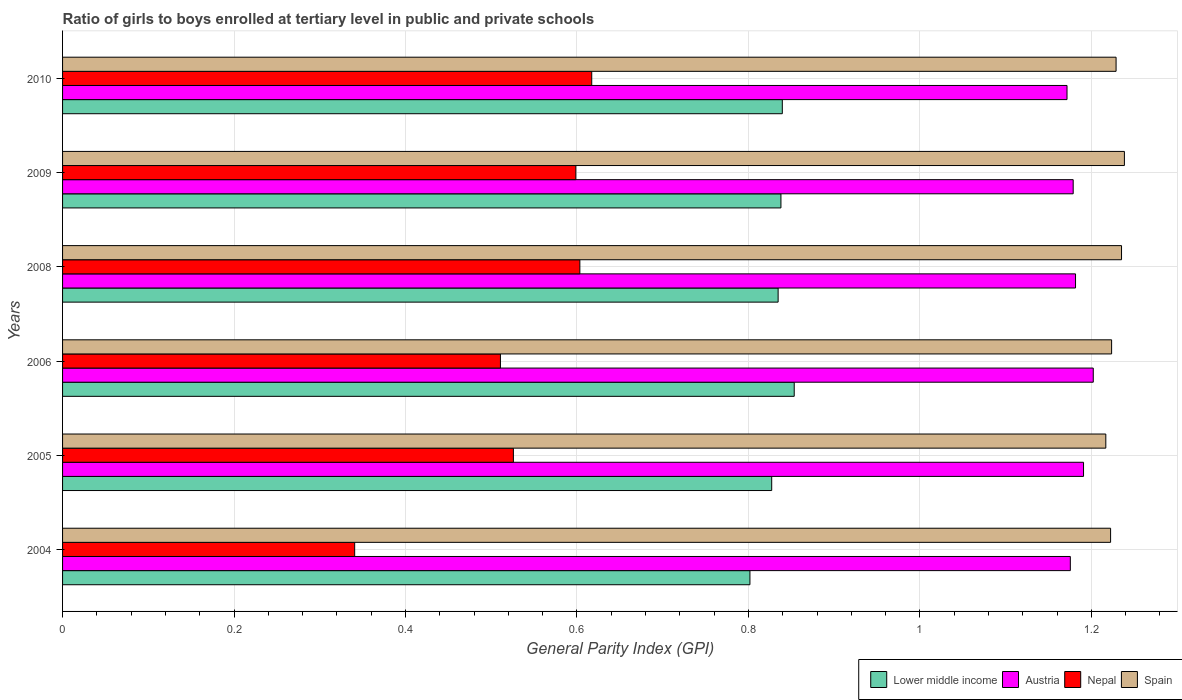Are the number of bars per tick equal to the number of legend labels?
Provide a succinct answer. Yes. How many bars are there on the 5th tick from the top?
Keep it short and to the point. 4. How many bars are there on the 5th tick from the bottom?
Give a very brief answer. 4. What is the label of the 3rd group of bars from the top?
Keep it short and to the point. 2008. What is the general parity index in Spain in 2009?
Offer a very short reply. 1.24. Across all years, what is the maximum general parity index in Lower middle income?
Provide a succinct answer. 0.85. Across all years, what is the minimum general parity index in Spain?
Offer a terse response. 1.22. In which year was the general parity index in Nepal minimum?
Offer a terse response. 2004. What is the total general parity index in Spain in the graph?
Your response must be concise. 7.37. What is the difference between the general parity index in Nepal in 2004 and that in 2009?
Your response must be concise. -0.26. What is the difference between the general parity index in Lower middle income in 2004 and the general parity index in Spain in 2010?
Keep it short and to the point. -0.43. What is the average general parity index in Spain per year?
Offer a very short reply. 1.23. In the year 2006, what is the difference between the general parity index in Nepal and general parity index in Austria?
Give a very brief answer. -0.69. What is the ratio of the general parity index in Lower middle income in 2009 to that in 2010?
Provide a short and direct response. 1. What is the difference between the highest and the second highest general parity index in Spain?
Ensure brevity in your answer.  0. What is the difference between the highest and the lowest general parity index in Nepal?
Your answer should be compact. 0.28. Is the sum of the general parity index in Austria in 2008 and 2010 greater than the maximum general parity index in Lower middle income across all years?
Offer a very short reply. Yes. Is it the case that in every year, the sum of the general parity index in Spain and general parity index in Nepal is greater than the sum of general parity index in Lower middle income and general parity index in Austria?
Give a very brief answer. No. What does the 4th bar from the top in 2010 represents?
Give a very brief answer. Lower middle income. What does the 1st bar from the bottom in 2004 represents?
Ensure brevity in your answer.  Lower middle income. Is it the case that in every year, the sum of the general parity index in Spain and general parity index in Nepal is greater than the general parity index in Austria?
Offer a very short reply. Yes. Are all the bars in the graph horizontal?
Give a very brief answer. Yes. What is the difference between two consecutive major ticks on the X-axis?
Provide a short and direct response. 0.2. Does the graph contain any zero values?
Keep it short and to the point. No. Where does the legend appear in the graph?
Ensure brevity in your answer.  Bottom right. How many legend labels are there?
Ensure brevity in your answer.  4. What is the title of the graph?
Provide a short and direct response. Ratio of girls to boys enrolled at tertiary level in public and private schools. What is the label or title of the X-axis?
Your response must be concise. General Parity Index (GPI). What is the General Parity Index (GPI) of Lower middle income in 2004?
Your response must be concise. 0.8. What is the General Parity Index (GPI) in Austria in 2004?
Keep it short and to the point. 1.18. What is the General Parity Index (GPI) of Nepal in 2004?
Ensure brevity in your answer.  0.34. What is the General Parity Index (GPI) in Spain in 2004?
Offer a very short reply. 1.22. What is the General Parity Index (GPI) in Lower middle income in 2005?
Provide a succinct answer. 0.83. What is the General Parity Index (GPI) in Austria in 2005?
Offer a very short reply. 1.19. What is the General Parity Index (GPI) in Nepal in 2005?
Offer a terse response. 0.53. What is the General Parity Index (GPI) in Spain in 2005?
Offer a very short reply. 1.22. What is the General Parity Index (GPI) in Lower middle income in 2006?
Provide a succinct answer. 0.85. What is the General Parity Index (GPI) in Austria in 2006?
Your answer should be very brief. 1.2. What is the General Parity Index (GPI) in Nepal in 2006?
Make the answer very short. 0.51. What is the General Parity Index (GPI) of Spain in 2006?
Provide a short and direct response. 1.22. What is the General Parity Index (GPI) of Lower middle income in 2008?
Offer a very short reply. 0.83. What is the General Parity Index (GPI) of Austria in 2008?
Make the answer very short. 1.18. What is the General Parity Index (GPI) of Nepal in 2008?
Keep it short and to the point. 0.6. What is the General Parity Index (GPI) in Spain in 2008?
Your answer should be very brief. 1.24. What is the General Parity Index (GPI) of Lower middle income in 2009?
Offer a very short reply. 0.84. What is the General Parity Index (GPI) in Austria in 2009?
Offer a very short reply. 1.18. What is the General Parity Index (GPI) of Nepal in 2009?
Your response must be concise. 0.6. What is the General Parity Index (GPI) in Spain in 2009?
Provide a short and direct response. 1.24. What is the General Parity Index (GPI) of Lower middle income in 2010?
Provide a short and direct response. 0.84. What is the General Parity Index (GPI) of Austria in 2010?
Provide a short and direct response. 1.17. What is the General Parity Index (GPI) in Nepal in 2010?
Give a very brief answer. 0.62. What is the General Parity Index (GPI) in Spain in 2010?
Your response must be concise. 1.23. Across all years, what is the maximum General Parity Index (GPI) in Lower middle income?
Provide a succinct answer. 0.85. Across all years, what is the maximum General Parity Index (GPI) in Austria?
Your answer should be compact. 1.2. Across all years, what is the maximum General Parity Index (GPI) of Nepal?
Offer a very short reply. 0.62. Across all years, what is the maximum General Parity Index (GPI) of Spain?
Keep it short and to the point. 1.24. Across all years, what is the minimum General Parity Index (GPI) in Lower middle income?
Ensure brevity in your answer.  0.8. Across all years, what is the minimum General Parity Index (GPI) in Austria?
Your response must be concise. 1.17. Across all years, what is the minimum General Parity Index (GPI) in Nepal?
Keep it short and to the point. 0.34. Across all years, what is the minimum General Parity Index (GPI) in Spain?
Your response must be concise. 1.22. What is the total General Parity Index (GPI) in Lower middle income in the graph?
Offer a terse response. 4.99. What is the total General Parity Index (GPI) of Austria in the graph?
Your response must be concise. 7.1. What is the total General Parity Index (GPI) in Nepal in the graph?
Give a very brief answer. 3.2. What is the total General Parity Index (GPI) in Spain in the graph?
Your answer should be very brief. 7.37. What is the difference between the General Parity Index (GPI) of Lower middle income in 2004 and that in 2005?
Keep it short and to the point. -0.03. What is the difference between the General Parity Index (GPI) in Austria in 2004 and that in 2005?
Ensure brevity in your answer.  -0.02. What is the difference between the General Parity Index (GPI) of Nepal in 2004 and that in 2005?
Provide a succinct answer. -0.19. What is the difference between the General Parity Index (GPI) in Spain in 2004 and that in 2005?
Give a very brief answer. 0.01. What is the difference between the General Parity Index (GPI) in Lower middle income in 2004 and that in 2006?
Provide a short and direct response. -0.05. What is the difference between the General Parity Index (GPI) in Austria in 2004 and that in 2006?
Keep it short and to the point. -0.03. What is the difference between the General Parity Index (GPI) in Nepal in 2004 and that in 2006?
Offer a terse response. -0.17. What is the difference between the General Parity Index (GPI) of Spain in 2004 and that in 2006?
Provide a succinct answer. -0. What is the difference between the General Parity Index (GPI) in Lower middle income in 2004 and that in 2008?
Offer a very short reply. -0.03. What is the difference between the General Parity Index (GPI) in Austria in 2004 and that in 2008?
Provide a succinct answer. -0.01. What is the difference between the General Parity Index (GPI) in Nepal in 2004 and that in 2008?
Make the answer very short. -0.26. What is the difference between the General Parity Index (GPI) of Spain in 2004 and that in 2008?
Provide a succinct answer. -0.01. What is the difference between the General Parity Index (GPI) in Lower middle income in 2004 and that in 2009?
Make the answer very short. -0.04. What is the difference between the General Parity Index (GPI) in Austria in 2004 and that in 2009?
Ensure brevity in your answer.  -0. What is the difference between the General Parity Index (GPI) in Nepal in 2004 and that in 2009?
Offer a very short reply. -0.26. What is the difference between the General Parity Index (GPI) in Spain in 2004 and that in 2009?
Give a very brief answer. -0.02. What is the difference between the General Parity Index (GPI) of Lower middle income in 2004 and that in 2010?
Provide a succinct answer. -0.04. What is the difference between the General Parity Index (GPI) of Austria in 2004 and that in 2010?
Your response must be concise. 0. What is the difference between the General Parity Index (GPI) in Nepal in 2004 and that in 2010?
Keep it short and to the point. -0.28. What is the difference between the General Parity Index (GPI) in Spain in 2004 and that in 2010?
Provide a succinct answer. -0.01. What is the difference between the General Parity Index (GPI) of Lower middle income in 2005 and that in 2006?
Your response must be concise. -0.03. What is the difference between the General Parity Index (GPI) of Austria in 2005 and that in 2006?
Your answer should be compact. -0.01. What is the difference between the General Parity Index (GPI) of Nepal in 2005 and that in 2006?
Keep it short and to the point. 0.02. What is the difference between the General Parity Index (GPI) of Spain in 2005 and that in 2006?
Give a very brief answer. -0.01. What is the difference between the General Parity Index (GPI) of Lower middle income in 2005 and that in 2008?
Provide a succinct answer. -0.01. What is the difference between the General Parity Index (GPI) in Austria in 2005 and that in 2008?
Keep it short and to the point. 0.01. What is the difference between the General Parity Index (GPI) of Nepal in 2005 and that in 2008?
Keep it short and to the point. -0.08. What is the difference between the General Parity Index (GPI) of Spain in 2005 and that in 2008?
Keep it short and to the point. -0.02. What is the difference between the General Parity Index (GPI) of Lower middle income in 2005 and that in 2009?
Offer a very short reply. -0.01. What is the difference between the General Parity Index (GPI) in Austria in 2005 and that in 2009?
Give a very brief answer. 0.01. What is the difference between the General Parity Index (GPI) of Nepal in 2005 and that in 2009?
Make the answer very short. -0.07. What is the difference between the General Parity Index (GPI) in Spain in 2005 and that in 2009?
Give a very brief answer. -0.02. What is the difference between the General Parity Index (GPI) of Lower middle income in 2005 and that in 2010?
Offer a terse response. -0.01. What is the difference between the General Parity Index (GPI) of Austria in 2005 and that in 2010?
Offer a very short reply. 0.02. What is the difference between the General Parity Index (GPI) in Nepal in 2005 and that in 2010?
Your answer should be compact. -0.09. What is the difference between the General Parity Index (GPI) in Spain in 2005 and that in 2010?
Offer a terse response. -0.01. What is the difference between the General Parity Index (GPI) in Lower middle income in 2006 and that in 2008?
Give a very brief answer. 0.02. What is the difference between the General Parity Index (GPI) of Austria in 2006 and that in 2008?
Make the answer very short. 0.02. What is the difference between the General Parity Index (GPI) in Nepal in 2006 and that in 2008?
Offer a very short reply. -0.09. What is the difference between the General Parity Index (GPI) in Spain in 2006 and that in 2008?
Make the answer very short. -0.01. What is the difference between the General Parity Index (GPI) in Lower middle income in 2006 and that in 2009?
Make the answer very short. 0.02. What is the difference between the General Parity Index (GPI) of Austria in 2006 and that in 2009?
Your answer should be compact. 0.02. What is the difference between the General Parity Index (GPI) in Nepal in 2006 and that in 2009?
Give a very brief answer. -0.09. What is the difference between the General Parity Index (GPI) of Spain in 2006 and that in 2009?
Keep it short and to the point. -0.01. What is the difference between the General Parity Index (GPI) of Lower middle income in 2006 and that in 2010?
Your answer should be compact. 0.01. What is the difference between the General Parity Index (GPI) in Austria in 2006 and that in 2010?
Provide a short and direct response. 0.03. What is the difference between the General Parity Index (GPI) of Nepal in 2006 and that in 2010?
Provide a succinct answer. -0.11. What is the difference between the General Parity Index (GPI) in Spain in 2006 and that in 2010?
Ensure brevity in your answer.  -0.01. What is the difference between the General Parity Index (GPI) in Lower middle income in 2008 and that in 2009?
Provide a short and direct response. -0. What is the difference between the General Parity Index (GPI) of Austria in 2008 and that in 2009?
Provide a short and direct response. 0. What is the difference between the General Parity Index (GPI) in Nepal in 2008 and that in 2009?
Offer a very short reply. 0. What is the difference between the General Parity Index (GPI) of Spain in 2008 and that in 2009?
Offer a very short reply. -0. What is the difference between the General Parity Index (GPI) of Lower middle income in 2008 and that in 2010?
Ensure brevity in your answer.  -0. What is the difference between the General Parity Index (GPI) of Austria in 2008 and that in 2010?
Provide a succinct answer. 0.01. What is the difference between the General Parity Index (GPI) of Nepal in 2008 and that in 2010?
Make the answer very short. -0.01. What is the difference between the General Parity Index (GPI) of Spain in 2008 and that in 2010?
Ensure brevity in your answer.  0.01. What is the difference between the General Parity Index (GPI) in Lower middle income in 2009 and that in 2010?
Provide a short and direct response. -0. What is the difference between the General Parity Index (GPI) in Austria in 2009 and that in 2010?
Give a very brief answer. 0.01. What is the difference between the General Parity Index (GPI) of Nepal in 2009 and that in 2010?
Offer a terse response. -0.02. What is the difference between the General Parity Index (GPI) of Spain in 2009 and that in 2010?
Your answer should be compact. 0.01. What is the difference between the General Parity Index (GPI) of Lower middle income in 2004 and the General Parity Index (GPI) of Austria in 2005?
Make the answer very short. -0.39. What is the difference between the General Parity Index (GPI) in Lower middle income in 2004 and the General Parity Index (GPI) in Nepal in 2005?
Keep it short and to the point. 0.28. What is the difference between the General Parity Index (GPI) in Lower middle income in 2004 and the General Parity Index (GPI) in Spain in 2005?
Give a very brief answer. -0.42. What is the difference between the General Parity Index (GPI) in Austria in 2004 and the General Parity Index (GPI) in Nepal in 2005?
Make the answer very short. 0.65. What is the difference between the General Parity Index (GPI) of Austria in 2004 and the General Parity Index (GPI) of Spain in 2005?
Offer a very short reply. -0.04. What is the difference between the General Parity Index (GPI) of Nepal in 2004 and the General Parity Index (GPI) of Spain in 2005?
Your answer should be very brief. -0.88. What is the difference between the General Parity Index (GPI) in Lower middle income in 2004 and the General Parity Index (GPI) in Austria in 2006?
Keep it short and to the point. -0.4. What is the difference between the General Parity Index (GPI) in Lower middle income in 2004 and the General Parity Index (GPI) in Nepal in 2006?
Offer a very short reply. 0.29. What is the difference between the General Parity Index (GPI) in Lower middle income in 2004 and the General Parity Index (GPI) in Spain in 2006?
Keep it short and to the point. -0.42. What is the difference between the General Parity Index (GPI) of Austria in 2004 and the General Parity Index (GPI) of Nepal in 2006?
Your answer should be compact. 0.66. What is the difference between the General Parity Index (GPI) of Austria in 2004 and the General Parity Index (GPI) of Spain in 2006?
Offer a very short reply. -0.05. What is the difference between the General Parity Index (GPI) in Nepal in 2004 and the General Parity Index (GPI) in Spain in 2006?
Offer a terse response. -0.88. What is the difference between the General Parity Index (GPI) in Lower middle income in 2004 and the General Parity Index (GPI) in Austria in 2008?
Your answer should be compact. -0.38. What is the difference between the General Parity Index (GPI) in Lower middle income in 2004 and the General Parity Index (GPI) in Nepal in 2008?
Give a very brief answer. 0.2. What is the difference between the General Parity Index (GPI) in Lower middle income in 2004 and the General Parity Index (GPI) in Spain in 2008?
Make the answer very short. -0.43. What is the difference between the General Parity Index (GPI) in Austria in 2004 and the General Parity Index (GPI) in Nepal in 2008?
Offer a terse response. 0.57. What is the difference between the General Parity Index (GPI) in Austria in 2004 and the General Parity Index (GPI) in Spain in 2008?
Offer a very short reply. -0.06. What is the difference between the General Parity Index (GPI) in Nepal in 2004 and the General Parity Index (GPI) in Spain in 2008?
Ensure brevity in your answer.  -0.89. What is the difference between the General Parity Index (GPI) of Lower middle income in 2004 and the General Parity Index (GPI) of Austria in 2009?
Offer a very short reply. -0.38. What is the difference between the General Parity Index (GPI) in Lower middle income in 2004 and the General Parity Index (GPI) in Nepal in 2009?
Your answer should be very brief. 0.2. What is the difference between the General Parity Index (GPI) in Lower middle income in 2004 and the General Parity Index (GPI) in Spain in 2009?
Give a very brief answer. -0.44. What is the difference between the General Parity Index (GPI) of Austria in 2004 and the General Parity Index (GPI) of Nepal in 2009?
Provide a short and direct response. 0.58. What is the difference between the General Parity Index (GPI) of Austria in 2004 and the General Parity Index (GPI) of Spain in 2009?
Make the answer very short. -0.06. What is the difference between the General Parity Index (GPI) in Nepal in 2004 and the General Parity Index (GPI) in Spain in 2009?
Offer a terse response. -0.9. What is the difference between the General Parity Index (GPI) of Lower middle income in 2004 and the General Parity Index (GPI) of Austria in 2010?
Provide a short and direct response. -0.37. What is the difference between the General Parity Index (GPI) in Lower middle income in 2004 and the General Parity Index (GPI) in Nepal in 2010?
Provide a succinct answer. 0.18. What is the difference between the General Parity Index (GPI) in Lower middle income in 2004 and the General Parity Index (GPI) in Spain in 2010?
Ensure brevity in your answer.  -0.43. What is the difference between the General Parity Index (GPI) in Austria in 2004 and the General Parity Index (GPI) in Nepal in 2010?
Offer a very short reply. 0.56. What is the difference between the General Parity Index (GPI) in Austria in 2004 and the General Parity Index (GPI) in Spain in 2010?
Your answer should be compact. -0.05. What is the difference between the General Parity Index (GPI) in Nepal in 2004 and the General Parity Index (GPI) in Spain in 2010?
Provide a succinct answer. -0.89. What is the difference between the General Parity Index (GPI) of Lower middle income in 2005 and the General Parity Index (GPI) of Austria in 2006?
Your answer should be compact. -0.38. What is the difference between the General Parity Index (GPI) of Lower middle income in 2005 and the General Parity Index (GPI) of Nepal in 2006?
Your answer should be compact. 0.32. What is the difference between the General Parity Index (GPI) in Lower middle income in 2005 and the General Parity Index (GPI) in Spain in 2006?
Ensure brevity in your answer.  -0.4. What is the difference between the General Parity Index (GPI) in Austria in 2005 and the General Parity Index (GPI) in Nepal in 2006?
Provide a succinct answer. 0.68. What is the difference between the General Parity Index (GPI) in Austria in 2005 and the General Parity Index (GPI) in Spain in 2006?
Make the answer very short. -0.03. What is the difference between the General Parity Index (GPI) of Nepal in 2005 and the General Parity Index (GPI) of Spain in 2006?
Provide a succinct answer. -0.7. What is the difference between the General Parity Index (GPI) in Lower middle income in 2005 and the General Parity Index (GPI) in Austria in 2008?
Offer a very short reply. -0.35. What is the difference between the General Parity Index (GPI) of Lower middle income in 2005 and the General Parity Index (GPI) of Nepal in 2008?
Offer a very short reply. 0.22. What is the difference between the General Parity Index (GPI) of Lower middle income in 2005 and the General Parity Index (GPI) of Spain in 2008?
Your response must be concise. -0.41. What is the difference between the General Parity Index (GPI) in Austria in 2005 and the General Parity Index (GPI) in Nepal in 2008?
Keep it short and to the point. 0.59. What is the difference between the General Parity Index (GPI) of Austria in 2005 and the General Parity Index (GPI) of Spain in 2008?
Offer a very short reply. -0.04. What is the difference between the General Parity Index (GPI) in Nepal in 2005 and the General Parity Index (GPI) in Spain in 2008?
Give a very brief answer. -0.71. What is the difference between the General Parity Index (GPI) of Lower middle income in 2005 and the General Parity Index (GPI) of Austria in 2009?
Ensure brevity in your answer.  -0.35. What is the difference between the General Parity Index (GPI) in Lower middle income in 2005 and the General Parity Index (GPI) in Nepal in 2009?
Make the answer very short. 0.23. What is the difference between the General Parity Index (GPI) in Lower middle income in 2005 and the General Parity Index (GPI) in Spain in 2009?
Offer a very short reply. -0.41. What is the difference between the General Parity Index (GPI) in Austria in 2005 and the General Parity Index (GPI) in Nepal in 2009?
Your response must be concise. 0.59. What is the difference between the General Parity Index (GPI) in Austria in 2005 and the General Parity Index (GPI) in Spain in 2009?
Your response must be concise. -0.05. What is the difference between the General Parity Index (GPI) in Nepal in 2005 and the General Parity Index (GPI) in Spain in 2009?
Give a very brief answer. -0.71. What is the difference between the General Parity Index (GPI) of Lower middle income in 2005 and the General Parity Index (GPI) of Austria in 2010?
Provide a short and direct response. -0.34. What is the difference between the General Parity Index (GPI) of Lower middle income in 2005 and the General Parity Index (GPI) of Nepal in 2010?
Offer a very short reply. 0.21. What is the difference between the General Parity Index (GPI) in Lower middle income in 2005 and the General Parity Index (GPI) in Spain in 2010?
Your answer should be very brief. -0.4. What is the difference between the General Parity Index (GPI) of Austria in 2005 and the General Parity Index (GPI) of Nepal in 2010?
Provide a succinct answer. 0.57. What is the difference between the General Parity Index (GPI) of Austria in 2005 and the General Parity Index (GPI) of Spain in 2010?
Your response must be concise. -0.04. What is the difference between the General Parity Index (GPI) in Nepal in 2005 and the General Parity Index (GPI) in Spain in 2010?
Ensure brevity in your answer.  -0.7. What is the difference between the General Parity Index (GPI) in Lower middle income in 2006 and the General Parity Index (GPI) in Austria in 2008?
Give a very brief answer. -0.33. What is the difference between the General Parity Index (GPI) in Lower middle income in 2006 and the General Parity Index (GPI) in Nepal in 2008?
Provide a short and direct response. 0.25. What is the difference between the General Parity Index (GPI) of Lower middle income in 2006 and the General Parity Index (GPI) of Spain in 2008?
Make the answer very short. -0.38. What is the difference between the General Parity Index (GPI) of Austria in 2006 and the General Parity Index (GPI) of Nepal in 2008?
Your response must be concise. 0.6. What is the difference between the General Parity Index (GPI) of Austria in 2006 and the General Parity Index (GPI) of Spain in 2008?
Provide a short and direct response. -0.03. What is the difference between the General Parity Index (GPI) of Nepal in 2006 and the General Parity Index (GPI) of Spain in 2008?
Provide a short and direct response. -0.72. What is the difference between the General Parity Index (GPI) of Lower middle income in 2006 and the General Parity Index (GPI) of Austria in 2009?
Your answer should be very brief. -0.33. What is the difference between the General Parity Index (GPI) in Lower middle income in 2006 and the General Parity Index (GPI) in Nepal in 2009?
Offer a terse response. 0.25. What is the difference between the General Parity Index (GPI) in Lower middle income in 2006 and the General Parity Index (GPI) in Spain in 2009?
Your answer should be compact. -0.39. What is the difference between the General Parity Index (GPI) of Austria in 2006 and the General Parity Index (GPI) of Nepal in 2009?
Your response must be concise. 0.6. What is the difference between the General Parity Index (GPI) of Austria in 2006 and the General Parity Index (GPI) of Spain in 2009?
Offer a terse response. -0.04. What is the difference between the General Parity Index (GPI) in Nepal in 2006 and the General Parity Index (GPI) in Spain in 2009?
Offer a terse response. -0.73. What is the difference between the General Parity Index (GPI) of Lower middle income in 2006 and the General Parity Index (GPI) of Austria in 2010?
Your answer should be very brief. -0.32. What is the difference between the General Parity Index (GPI) of Lower middle income in 2006 and the General Parity Index (GPI) of Nepal in 2010?
Your response must be concise. 0.24. What is the difference between the General Parity Index (GPI) of Lower middle income in 2006 and the General Parity Index (GPI) of Spain in 2010?
Give a very brief answer. -0.38. What is the difference between the General Parity Index (GPI) of Austria in 2006 and the General Parity Index (GPI) of Nepal in 2010?
Your response must be concise. 0.58. What is the difference between the General Parity Index (GPI) in Austria in 2006 and the General Parity Index (GPI) in Spain in 2010?
Offer a very short reply. -0.03. What is the difference between the General Parity Index (GPI) in Nepal in 2006 and the General Parity Index (GPI) in Spain in 2010?
Ensure brevity in your answer.  -0.72. What is the difference between the General Parity Index (GPI) of Lower middle income in 2008 and the General Parity Index (GPI) of Austria in 2009?
Ensure brevity in your answer.  -0.34. What is the difference between the General Parity Index (GPI) of Lower middle income in 2008 and the General Parity Index (GPI) of Nepal in 2009?
Provide a succinct answer. 0.24. What is the difference between the General Parity Index (GPI) of Lower middle income in 2008 and the General Parity Index (GPI) of Spain in 2009?
Provide a succinct answer. -0.4. What is the difference between the General Parity Index (GPI) in Austria in 2008 and the General Parity Index (GPI) in Nepal in 2009?
Give a very brief answer. 0.58. What is the difference between the General Parity Index (GPI) of Austria in 2008 and the General Parity Index (GPI) of Spain in 2009?
Keep it short and to the point. -0.06. What is the difference between the General Parity Index (GPI) of Nepal in 2008 and the General Parity Index (GPI) of Spain in 2009?
Provide a succinct answer. -0.64. What is the difference between the General Parity Index (GPI) in Lower middle income in 2008 and the General Parity Index (GPI) in Austria in 2010?
Offer a terse response. -0.34. What is the difference between the General Parity Index (GPI) in Lower middle income in 2008 and the General Parity Index (GPI) in Nepal in 2010?
Give a very brief answer. 0.22. What is the difference between the General Parity Index (GPI) of Lower middle income in 2008 and the General Parity Index (GPI) of Spain in 2010?
Provide a succinct answer. -0.39. What is the difference between the General Parity Index (GPI) in Austria in 2008 and the General Parity Index (GPI) in Nepal in 2010?
Offer a very short reply. 0.56. What is the difference between the General Parity Index (GPI) of Austria in 2008 and the General Parity Index (GPI) of Spain in 2010?
Keep it short and to the point. -0.05. What is the difference between the General Parity Index (GPI) of Nepal in 2008 and the General Parity Index (GPI) of Spain in 2010?
Provide a succinct answer. -0.63. What is the difference between the General Parity Index (GPI) of Lower middle income in 2009 and the General Parity Index (GPI) of Austria in 2010?
Your answer should be compact. -0.33. What is the difference between the General Parity Index (GPI) of Lower middle income in 2009 and the General Parity Index (GPI) of Nepal in 2010?
Offer a terse response. 0.22. What is the difference between the General Parity Index (GPI) in Lower middle income in 2009 and the General Parity Index (GPI) in Spain in 2010?
Your answer should be very brief. -0.39. What is the difference between the General Parity Index (GPI) of Austria in 2009 and the General Parity Index (GPI) of Nepal in 2010?
Keep it short and to the point. 0.56. What is the difference between the General Parity Index (GPI) in Austria in 2009 and the General Parity Index (GPI) in Spain in 2010?
Your answer should be very brief. -0.05. What is the difference between the General Parity Index (GPI) of Nepal in 2009 and the General Parity Index (GPI) of Spain in 2010?
Offer a terse response. -0.63. What is the average General Parity Index (GPI) of Lower middle income per year?
Offer a terse response. 0.83. What is the average General Parity Index (GPI) of Austria per year?
Ensure brevity in your answer.  1.18. What is the average General Parity Index (GPI) of Nepal per year?
Provide a succinct answer. 0.53. What is the average General Parity Index (GPI) of Spain per year?
Provide a succinct answer. 1.23. In the year 2004, what is the difference between the General Parity Index (GPI) of Lower middle income and General Parity Index (GPI) of Austria?
Offer a terse response. -0.37. In the year 2004, what is the difference between the General Parity Index (GPI) of Lower middle income and General Parity Index (GPI) of Nepal?
Give a very brief answer. 0.46. In the year 2004, what is the difference between the General Parity Index (GPI) of Lower middle income and General Parity Index (GPI) of Spain?
Make the answer very short. -0.42. In the year 2004, what is the difference between the General Parity Index (GPI) in Austria and General Parity Index (GPI) in Nepal?
Make the answer very short. 0.83. In the year 2004, what is the difference between the General Parity Index (GPI) in Austria and General Parity Index (GPI) in Spain?
Provide a succinct answer. -0.05. In the year 2004, what is the difference between the General Parity Index (GPI) of Nepal and General Parity Index (GPI) of Spain?
Your answer should be compact. -0.88. In the year 2005, what is the difference between the General Parity Index (GPI) in Lower middle income and General Parity Index (GPI) in Austria?
Your response must be concise. -0.36. In the year 2005, what is the difference between the General Parity Index (GPI) of Lower middle income and General Parity Index (GPI) of Nepal?
Make the answer very short. 0.3. In the year 2005, what is the difference between the General Parity Index (GPI) of Lower middle income and General Parity Index (GPI) of Spain?
Your response must be concise. -0.39. In the year 2005, what is the difference between the General Parity Index (GPI) of Austria and General Parity Index (GPI) of Nepal?
Your answer should be compact. 0.67. In the year 2005, what is the difference between the General Parity Index (GPI) of Austria and General Parity Index (GPI) of Spain?
Provide a short and direct response. -0.03. In the year 2005, what is the difference between the General Parity Index (GPI) of Nepal and General Parity Index (GPI) of Spain?
Make the answer very short. -0.69. In the year 2006, what is the difference between the General Parity Index (GPI) in Lower middle income and General Parity Index (GPI) in Austria?
Keep it short and to the point. -0.35. In the year 2006, what is the difference between the General Parity Index (GPI) of Lower middle income and General Parity Index (GPI) of Nepal?
Your answer should be compact. 0.34. In the year 2006, what is the difference between the General Parity Index (GPI) in Lower middle income and General Parity Index (GPI) in Spain?
Your answer should be very brief. -0.37. In the year 2006, what is the difference between the General Parity Index (GPI) of Austria and General Parity Index (GPI) of Nepal?
Make the answer very short. 0.69. In the year 2006, what is the difference between the General Parity Index (GPI) of Austria and General Parity Index (GPI) of Spain?
Your answer should be compact. -0.02. In the year 2006, what is the difference between the General Parity Index (GPI) in Nepal and General Parity Index (GPI) in Spain?
Your answer should be compact. -0.71. In the year 2008, what is the difference between the General Parity Index (GPI) of Lower middle income and General Parity Index (GPI) of Austria?
Provide a succinct answer. -0.35. In the year 2008, what is the difference between the General Parity Index (GPI) in Lower middle income and General Parity Index (GPI) in Nepal?
Offer a very short reply. 0.23. In the year 2008, what is the difference between the General Parity Index (GPI) of Lower middle income and General Parity Index (GPI) of Spain?
Ensure brevity in your answer.  -0.4. In the year 2008, what is the difference between the General Parity Index (GPI) in Austria and General Parity Index (GPI) in Nepal?
Offer a terse response. 0.58. In the year 2008, what is the difference between the General Parity Index (GPI) in Austria and General Parity Index (GPI) in Spain?
Keep it short and to the point. -0.05. In the year 2008, what is the difference between the General Parity Index (GPI) in Nepal and General Parity Index (GPI) in Spain?
Your answer should be very brief. -0.63. In the year 2009, what is the difference between the General Parity Index (GPI) of Lower middle income and General Parity Index (GPI) of Austria?
Ensure brevity in your answer.  -0.34. In the year 2009, what is the difference between the General Parity Index (GPI) in Lower middle income and General Parity Index (GPI) in Nepal?
Ensure brevity in your answer.  0.24. In the year 2009, what is the difference between the General Parity Index (GPI) of Lower middle income and General Parity Index (GPI) of Spain?
Your response must be concise. -0.4. In the year 2009, what is the difference between the General Parity Index (GPI) in Austria and General Parity Index (GPI) in Nepal?
Your response must be concise. 0.58. In the year 2009, what is the difference between the General Parity Index (GPI) of Austria and General Parity Index (GPI) of Spain?
Keep it short and to the point. -0.06. In the year 2009, what is the difference between the General Parity Index (GPI) in Nepal and General Parity Index (GPI) in Spain?
Offer a terse response. -0.64. In the year 2010, what is the difference between the General Parity Index (GPI) in Lower middle income and General Parity Index (GPI) in Austria?
Your answer should be compact. -0.33. In the year 2010, what is the difference between the General Parity Index (GPI) of Lower middle income and General Parity Index (GPI) of Nepal?
Ensure brevity in your answer.  0.22. In the year 2010, what is the difference between the General Parity Index (GPI) in Lower middle income and General Parity Index (GPI) in Spain?
Your answer should be compact. -0.39. In the year 2010, what is the difference between the General Parity Index (GPI) of Austria and General Parity Index (GPI) of Nepal?
Offer a very short reply. 0.55. In the year 2010, what is the difference between the General Parity Index (GPI) in Austria and General Parity Index (GPI) in Spain?
Give a very brief answer. -0.06. In the year 2010, what is the difference between the General Parity Index (GPI) of Nepal and General Parity Index (GPI) of Spain?
Provide a short and direct response. -0.61. What is the ratio of the General Parity Index (GPI) of Lower middle income in 2004 to that in 2005?
Your response must be concise. 0.97. What is the ratio of the General Parity Index (GPI) in Austria in 2004 to that in 2005?
Keep it short and to the point. 0.99. What is the ratio of the General Parity Index (GPI) of Nepal in 2004 to that in 2005?
Make the answer very short. 0.65. What is the ratio of the General Parity Index (GPI) in Spain in 2004 to that in 2005?
Make the answer very short. 1. What is the ratio of the General Parity Index (GPI) in Lower middle income in 2004 to that in 2006?
Offer a terse response. 0.94. What is the ratio of the General Parity Index (GPI) of Austria in 2004 to that in 2006?
Give a very brief answer. 0.98. What is the ratio of the General Parity Index (GPI) in Nepal in 2004 to that in 2006?
Give a very brief answer. 0.67. What is the ratio of the General Parity Index (GPI) of Spain in 2004 to that in 2006?
Offer a very short reply. 1. What is the ratio of the General Parity Index (GPI) of Lower middle income in 2004 to that in 2008?
Keep it short and to the point. 0.96. What is the ratio of the General Parity Index (GPI) of Nepal in 2004 to that in 2008?
Provide a succinct answer. 0.56. What is the ratio of the General Parity Index (GPI) of Spain in 2004 to that in 2008?
Your answer should be compact. 0.99. What is the ratio of the General Parity Index (GPI) of Lower middle income in 2004 to that in 2009?
Your answer should be compact. 0.96. What is the ratio of the General Parity Index (GPI) in Nepal in 2004 to that in 2009?
Provide a succinct answer. 0.57. What is the ratio of the General Parity Index (GPI) in Spain in 2004 to that in 2009?
Offer a terse response. 0.99. What is the ratio of the General Parity Index (GPI) in Lower middle income in 2004 to that in 2010?
Give a very brief answer. 0.95. What is the ratio of the General Parity Index (GPI) of Austria in 2004 to that in 2010?
Provide a succinct answer. 1. What is the ratio of the General Parity Index (GPI) of Nepal in 2004 to that in 2010?
Keep it short and to the point. 0.55. What is the ratio of the General Parity Index (GPI) in Lower middle income in 2005 to that in 2006?
Your response must be concise. 0.97. What is the ratio of the General Parity Index (GPI) of Austria in 2005 to that in 2006?
Offer a very short reply. 0.99. What is the ratio of the General Parity Index (GPI) in Nepal in 2005 to that in 2006?
Ensure brevity in your answer.  1.03. What is the ratio of the General Parity Index (GPI) of Spain in 2005 to that in 2006?
Your answer should be compact. 0.99. What is the ratio of the General Parity Index (GPI) in Austria in 2005 to that in 2008?
Give a very brief answer. 1.01. What is the ratio of the General Parity Index (GPI) in Nepal in 2005 to that in 2008?
Make the answer very short. 0.87. What is the ratio of the General Parity Index (GPI) in Spain in 2005 to that in 2008?
Your response must be concise. 0.99. What is the ratio of the General Parity Index (GPI) of Lower middle income in 2005 to that in 2009?
Make the answer very short. 0.99. What is the ratio of the General Parity Index (GPI) in Austria in 2005 to that in 2009?
Provide a succinct answer. 1.01. What is the ratio of the General Parity Index (GPI) of Nepal in 2005 to that in 2009?
Offer a very short reply. 0.88. What is the ratio of the General Parity Index (GPI) of Spain in 2005 to that in 2009?
Offer a very short reply. 0.98. What is the ratio of the General Parity Index (GPI) of Austria in 2005 to that in 2010?
Ensure brevity in your answer.  1.02. What is the ratio of the General Parity Index (GPI) of Nepal in 2005 to that in 2010?
Provide a short and direct response. 0.85. What is the ratio of the General Parity Index (GPI) in Spain in 2005 to that in 2010?
Offer a terse response. 0.99. What is the ratio of the General Parity Index (GPI) in Lower middle income in 2006 to that in 2008?
Your answer should be compact. 1.02. What is the ratio of the General Parity Index (GPI) of Austria in 2006 to that in 2008?
Keep it short and to the point. 1.02. What is the ratio of the General Parity Index (GPI) in Nepal in 2006 to that in 2008?
Provide a short and direct response. 0.85. What is the ratio of the General Parity Index (GPI) in Spain in 2006 to that in 2008?
Your response must be concise. 0.99. What is the ratio of the General Parity Index (GPI) in Lower middle income in 2006 to that in 2009?
Make the answer very short. 1.02. What is the ratio of the General Parity Index (GPI) in Austria in 2006 to that in 2009?
Keep it short and to the point. 1.02. What is the ratio of the General Parity Index (GPI) in Nepal in 2006 to that in 2009?
Your response must be concise. 0.85. What is the ratio of the General Parity Index (GPI) of Lower middle income in 2006 to that in 2010?
Offer a terse response. 1.02. What is the ratio of the General Parity Index (GPI) in Austria in 2006 to that in 2010?
Your answer should be compact. 1.03. What is the ratio of the General Parity Index (GPI) in Nepal in 2006 to that in 2010?
Provide a succinct answer. 0.83. What is the ratio of the General Parity Index (GPI) of Lower middle income in 2008 to that in 2009?
Offer a terse response. 1. What is the ratio of the General Parity Index (GPI) of Austria in 2008 to that in 2009?
Your answer should be very brief. 1. What is the ratio of the General Parity Index (GPI) in Nepal in 2008 to that in 2009?
Your answer should be compact. 1.01. What is the ratio of the General Parity Index (GPI) in Spain in 2008 to that in 2009?
Offer a very short reply. 1. What is the ratio of the General Parity Index (GPI) in Austria in 2008 to that in 2010?
Make the answer very short. 1.01. What is the ratio of the General Parity Index (GPI) of Nepal in 2008 to that in 2010?
Your answer should be very brief. 0.98. What is the ratio of the General Parity Index (GPI) of Spain in 2008 to that in 2010?
Offer a terse response. 1.01. What is the ratio of the General Parity Index (GPI) of Austria in 2009 to that in 2010?
Offer a terse response. 1.01. What is the ratio of the General Parity Index (GPI) of Nepal in 2009 to that in 2010?
Offer a terse response. 0.97. What is the ratio of the General Parity Index (GPI) of Spain in 2009 to that in 2010?
Offer a terse response. 1.01. What is the difference between the highest and the second highest General Parity Index (GPI) of Lower middle income?
Provide a short and direct response. 0.01. What is the difference between the highest and the second highest General Parity Index (GPI) of Austria?
Offer a terse response. 0.01. What is the difference between the highest and the second highest General Parity Index (GPI) of Nepal?
Ensure brevity in your answer.  0.01. What is the difference between the highest and the second highest General Parity Index (GPI) of Spain?
Give a very brief answer. 0. What is the difference between the highest and the lowest General Parity Index (GPI) in Lower middle income?
Offer a terse response. 0.05. What is the difference between the highest and the lowest General Parity Index (GPI) in Austria?
Your answer should be very brief. 0.03. What is the difference between the highest and the lowest General Parity Index (GPI) of Nepal?
Make the answer very short. 0.28. What is the difference between the highest and the lowest General Parity Index (GPI) of Spain?
Keep it short and to the point. 0.02. 